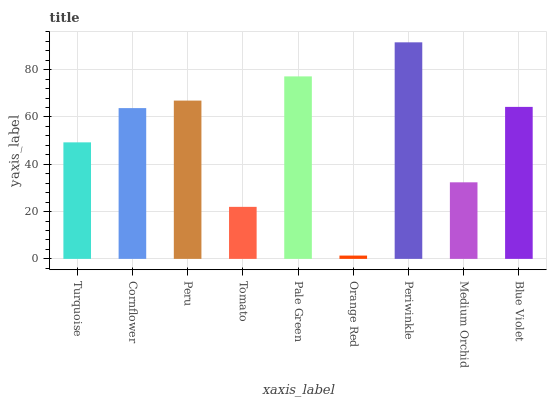Is Orange Red the minimum?
Answer yes or no. Yes. Is Periwinkle the maximum?
Answer yes or no. Yes. Is Cornflower the minimum?
Answer yes or no. No. Is Cornflower the maximum?
Answer yes or no. No. Is Cornflower greater than Turquoise?
Answer yes or no. Yes. Is Turquoise less than Cornflower?
Answer yes or no. Yes. Is Turquoise greater than Cornflower?
Answer yes or no. No. Is Cornflower less than Turquoise?
Answer yes or no. No. Is Cornflower the high median?
Answer yes or no. Yes. Is Cornflower the low median?
Answer yes or no. Yes. Is Blue Violet the high median?
Answer yes or no. No. Is Turquoise the low median?
Answer yes or no. No. 